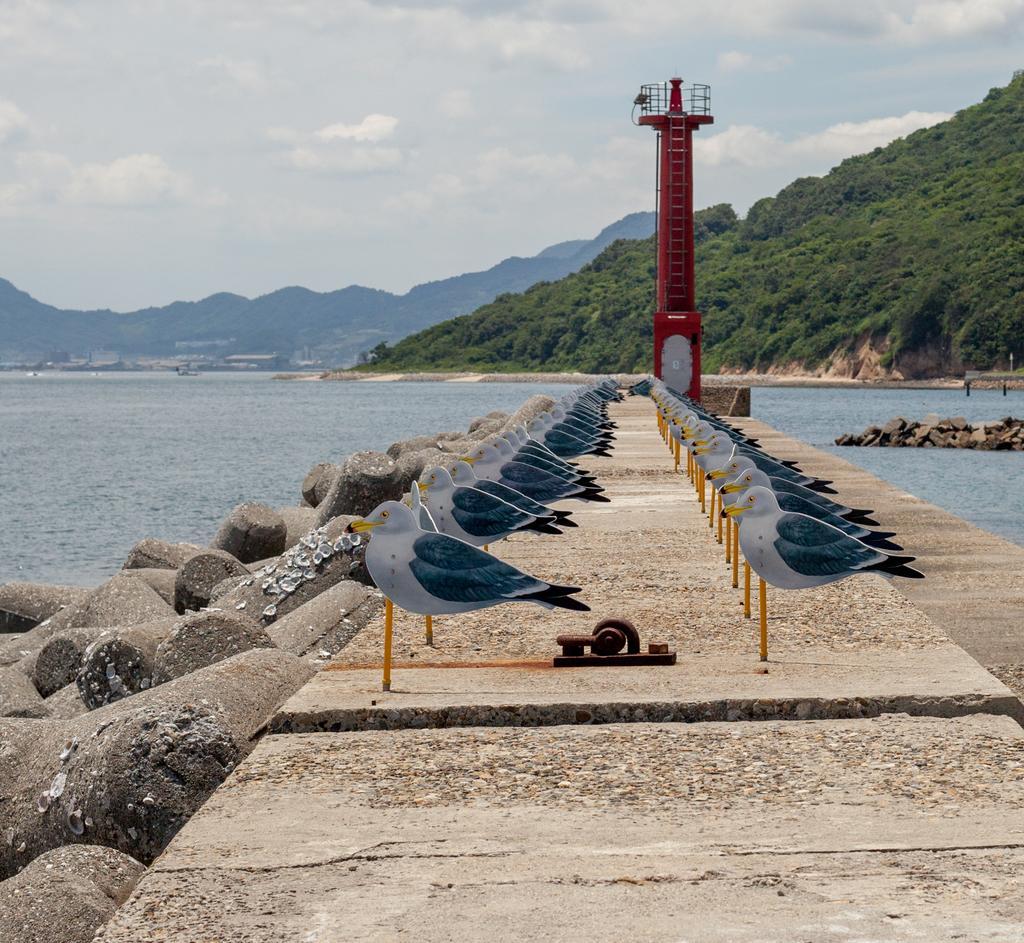Please provide a concise description of this image. There are few toy birds which are attached to an object are placed on the ground and there are mountains and water in the background. 